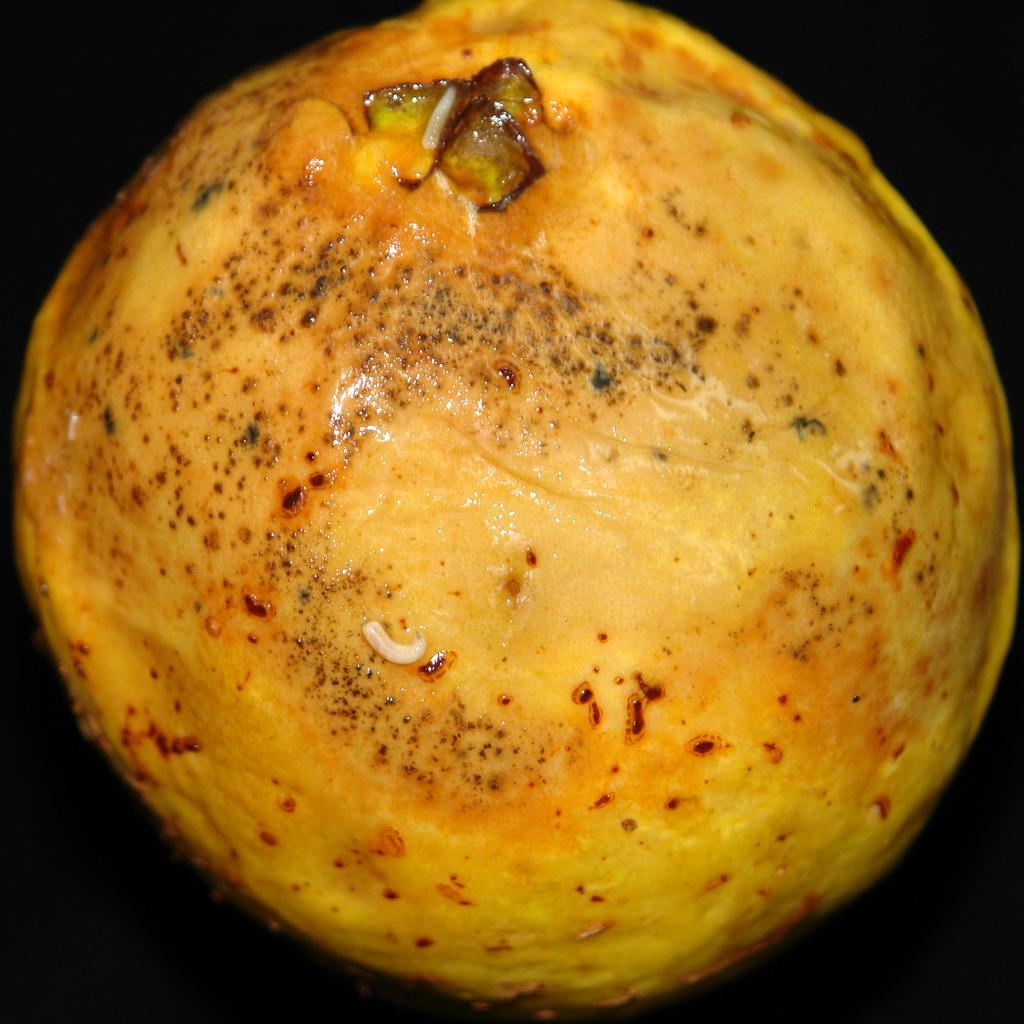What is the main subject of the image? There is a food item in the center of the image. What type of insurance policy is being discussed in the image? There is no mention of insurance in the image; it features a food item in the center. How many tomatoes are visible in the image? There is no reference to tomatoes in the image; it only shows a food item in the center. 